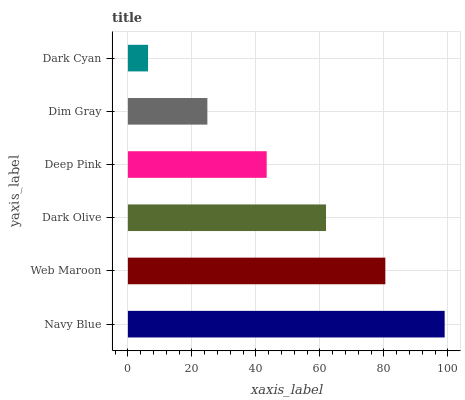Is Dark Cyan the minimum?
Answer yes or no. Yes. Is Navy Blue the maximum?
Answer yes or no. Yes. Is Web Maroon the minimum?
Answer yes or no. No. Is Web Maroon the maximum?
Answer yes or no. No. Is Navy Blue greater than Web Maroon?
Answer yes or no. Yes. Is Web Maroon less than Navy Blue?
Answer yes or no. Yes. Is Web Maroon greater than Navy Blue?
Answer yes or no. No. Is Navy Blue less than Web Maroon?
Answer yes or no. No. Is Dark Olive the high median?
Answer yes or no. Yes. Is Deep Pink the low median?
Answer yes or no. Yes. Is Web Maroon the high median?
Answer yes or no. No. Is Dark Olive the low median?
Answer yes or no. No. 